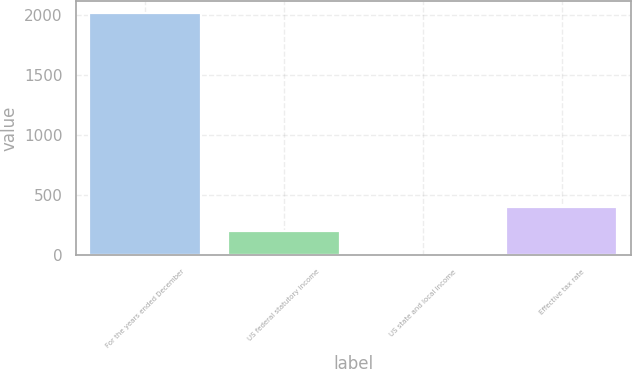Convert chart. <chart><loc_0><loc_0><loc_500><loc_500><bar_chart><fcel>For the years ended December<fcel>US federal statutory income<fcel>US state and local income<fcel>Effective tax rate<nl><fcel>2015<fcel>203.57<fcel>2.3<fcel>404.84<nl></chart> 